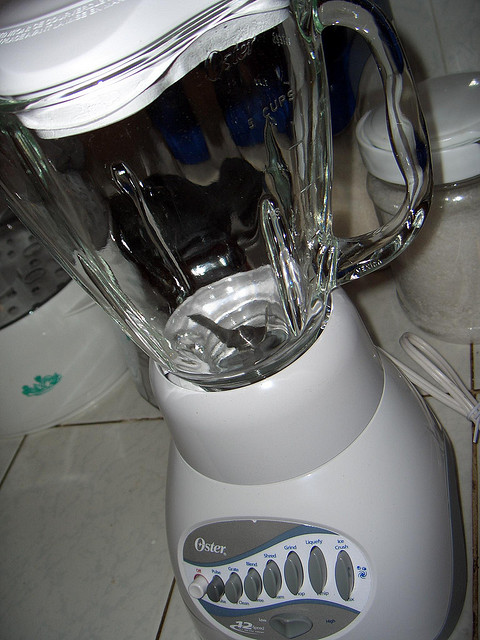<image>What is in the reflection of the vases? I am not sure. There might be a light or a hand in the reflection of the vases. What is in the reflection of the vases? I don't know what is in the reflection of the vases. It can be seen 'hand', 'light', 'cup' or nothing. 